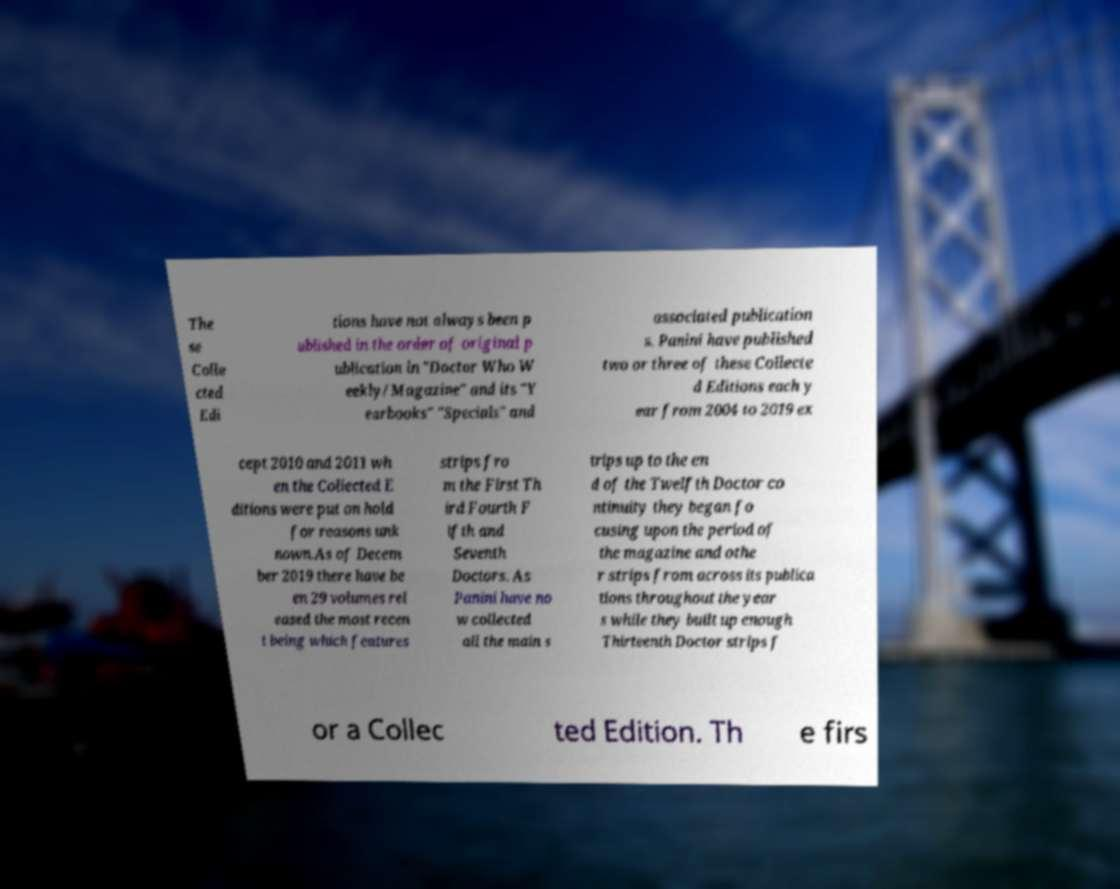Please read and relay the text visible in this image. What does it say? The se Colle cted Edi tions have not always been p ublished in the order of original p ublication in "Doctor Who W eekly/Magazine" and its "Y earbooks" "Specials" and associated publication s. Panini have published two or three of these Collecte d Editions each y ear from 2004 to 2019 ex cept 2010 and 2011 wh en the Collected E ditions were put on hold for reasons unk nown.As of Decem ber 2019 there have be en 29 volumes rel eased the most recen t being which features strips fro m the First Th ird Fourth F ifth and Seventh Doctors. As Panini have no w collected all the main s trips up to the en d of the Twelfth Doctor co ntinuity they began fo cusing upon the period of the magazine and othe r strips from across its publica tions throughout the year s while they built up enough Thirteenth Doctor strips f or a Collec ted Edition. Th e firs 